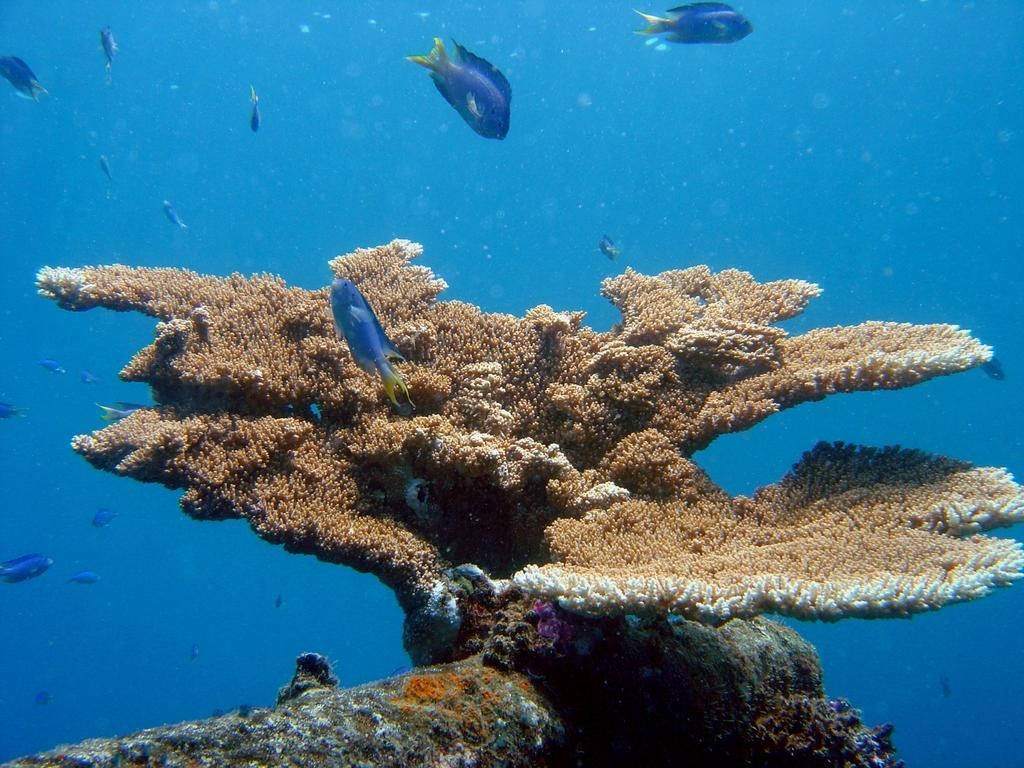What type of environment is shown in the image? The image depicts an underwater environment. What types of living organisms can be seen in the image? There are fish in the image. Are there any non-animal elements present in the image? Yes, there appears to be a plant in the image. Can you see a man wearing a mask in the image? No, there is no man wearing a mask in the image; it depicts an underwater environment with fish and a plant. 